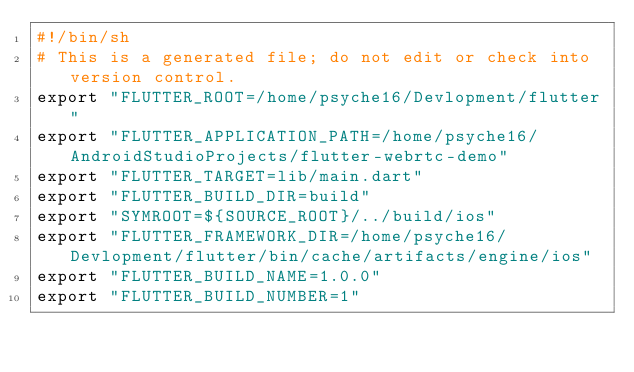Convert code to text. <code><loc_0><loc_0><loc_500><loc_500><_Bash_>#!/bin/sh
# This is a generated file; do not edit or check into version control.
export "FLUTTER_ROOT=/home/psyche16/Devlopment/flutter"
export "FLUTTER_APPLICATION_PATH=/home/psyche16/AndroidStudioProjects/flutter-webrtc-demo"
export "FLUTTER_TARGET=lib/main.dart"
export "FLUTTER_BUILD_DIR=build"
export "SYMROOT=${SOURCE_ROOT}/../build/ios"
export "FLUTTER_FRAMEWORK_DIR=/home/psyche16/Devlopment/flutter/bin/cache/artifacts/engine/ios"
export "FLUTTER_BUILD_NAME=1.0.0"
export "FLUTTER_BUILD_NUMBER=1"
</code> 